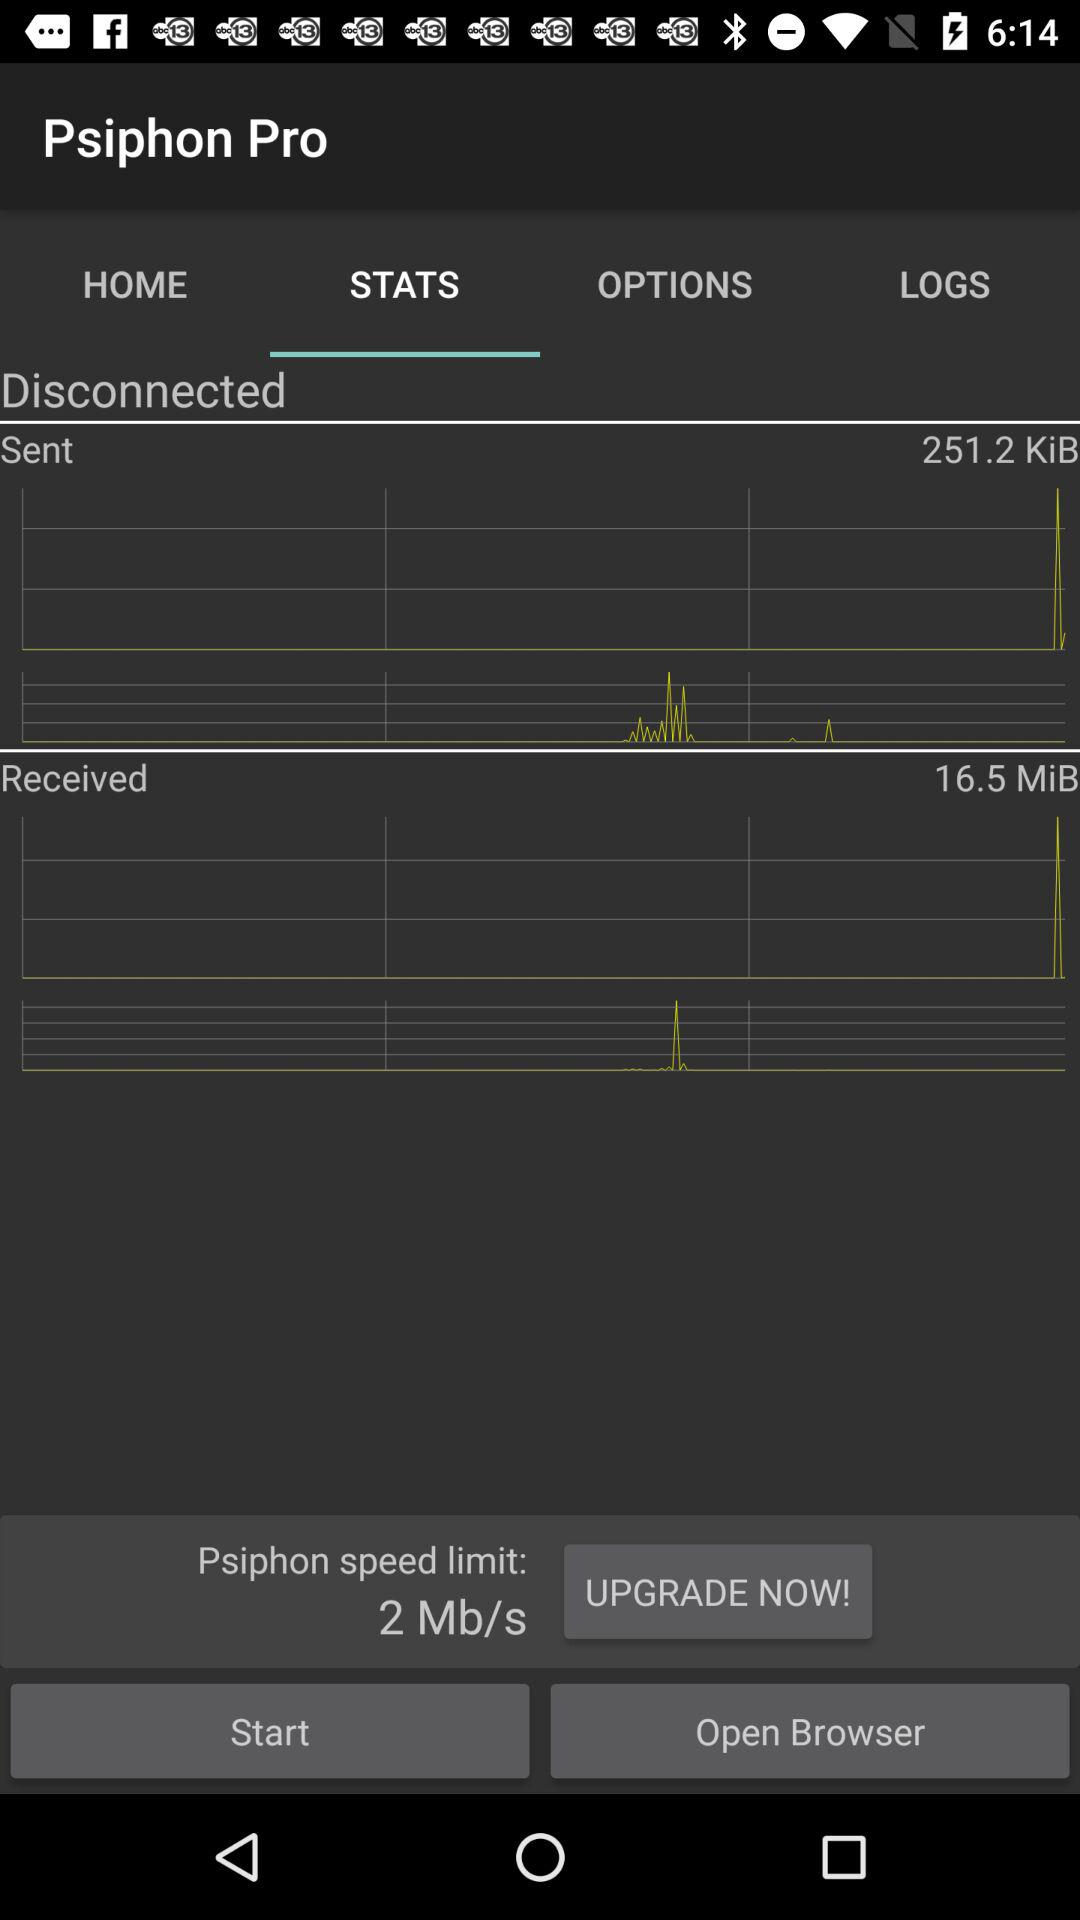What is the "Psiphon" speed limit? The speed limit is 2 Mb/s. 